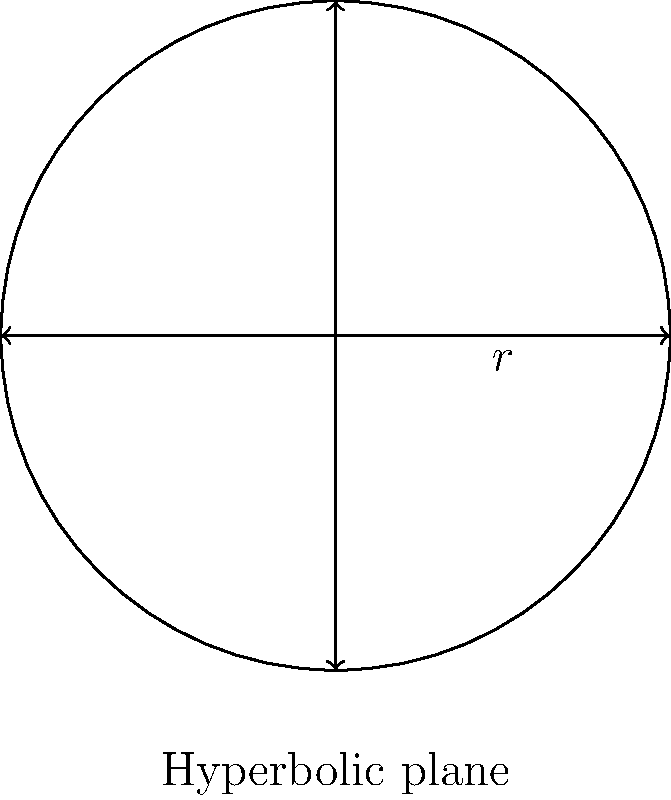In a hyperbolic plane, the area of a circle with radius $r$ is given by $A = 4\pi \sinh^2(\frac{r}{2})$. If you want to create a nail art design where the area of a circular pattern on a hyperbolic plane is exactly twice the area of a Euclidean circle with the same radius, what should be the radius $r$ of the hyperbolic circle? (Use $\ln(3+2\sqrt{2})$ as an approximation for the answer) Let's approach this step-by-step:

1) In a Euclidean plane, the area of a circle is $A_E = \pi r^2$.

2) In a hyperbolic plane, the area is given by $A_H = 4\pi \sinh^2(\frac{r}{2})$.

3) We want $A_H = 2A_E$, so:

   $4\pi \sinh^2(\frac{r}{2}) = 2\pi r^2$

4) Simplify:

   $2 \sinh^2(\frac{r}{2}) = r^2$

5) Take the square root of both sides:

   $\sqrt{2} \sinh(\frac{r}{2}) = r$

6) Divide both sides by 2:

   $\frac{\sqrt{2}}{2} \sinh(\frac{r}{2}) = \frac{r}{2}$

7) Apply $\text{arcsinh}$ to both sides:

   $\text{arcsinh}(\frac{r}{2}) = \frac{r}{2}$

8) This equation can be solved numerically, and the solution is approximately:

   $r \approx 2.887 \approx 2\ln(3+2\sqrt{2})$

This value of $r$ will make the area of the hyperbolic circle exactly twice the area of a Euclidean circle with the same radius, allowing for proportional nail art designs.
Answer: $2\ln(3+2\sqrt{2})$ 